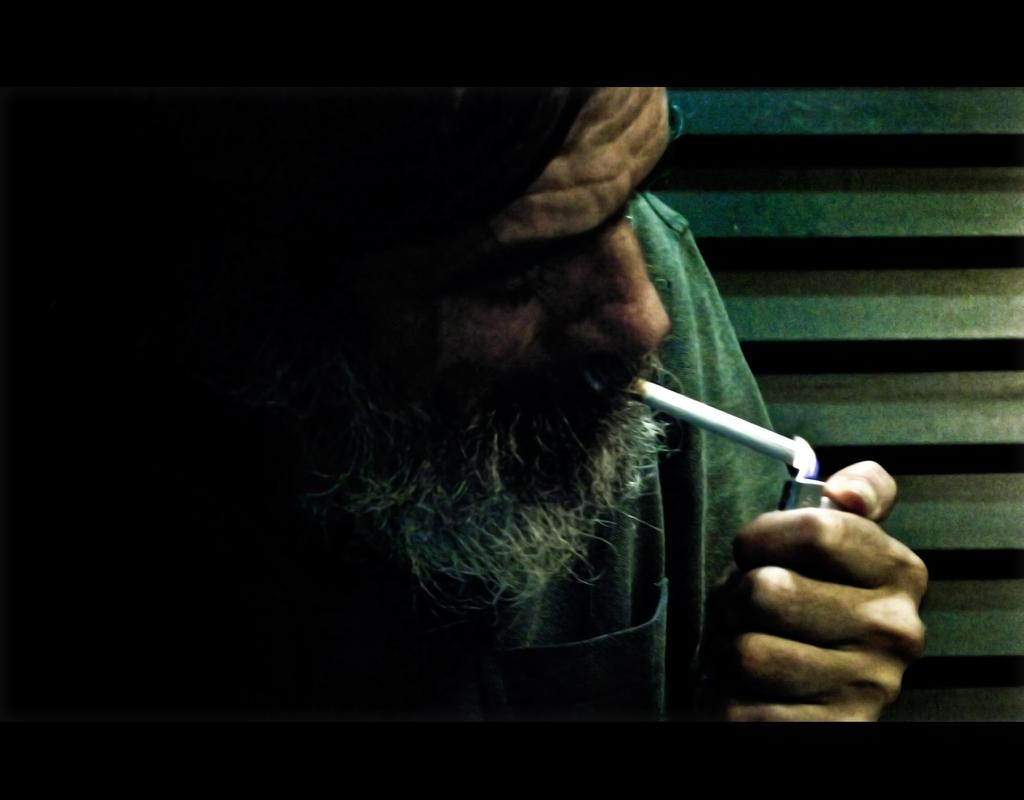Who is present in the image? There is a man in the image. What is the man doing in the image? The man has a cigarette in his mouth and is lighting it with a lighter. What can be seen in the background of the image? There is a wall in the background of the image. What type of question is being asked in the image? There is no question being asked in the image; the man is lighting a cigarette. How many screws can be seen in the image? There are no screws present in the image. 